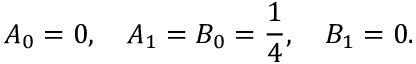Convert formula to latex. <formula><loc_0><loc_0><loc_500><loc_500>A _ { 0 } = 0 , \quad A _ { 1 } = B _ { 0 } = { \frac { 1 } { 4 } } , \quad B _ { 1 } = 0 .</formula> 